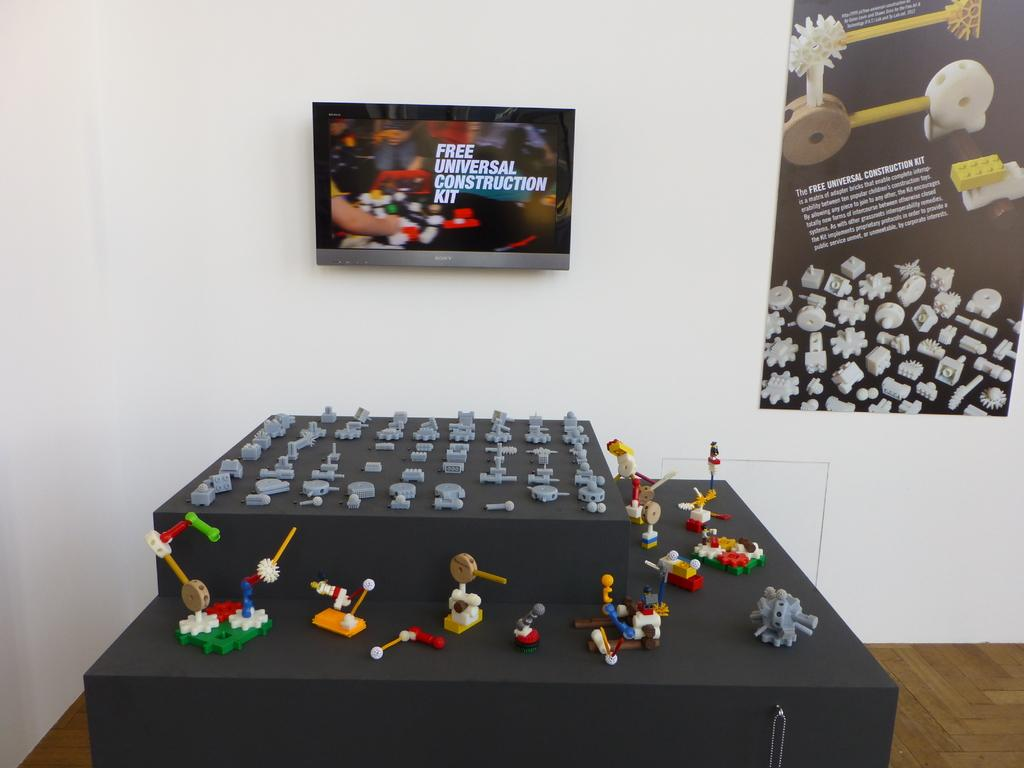Provide a one-sentence caption for the provided image. A table with small figures on display and an ad that says Free Universal Construction Kit. 